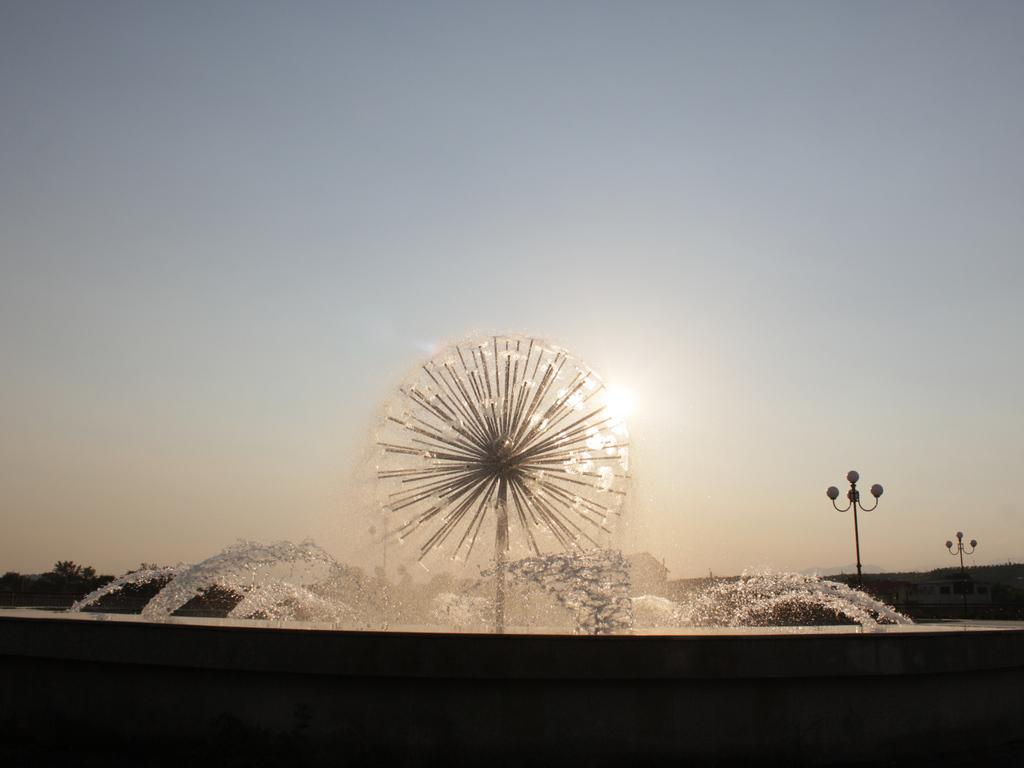What type of lighting can be seen in the image? There are street lights in the image. What natural element is visible in the image? There is water visible in the image. What can be seen in the background of the image? There are trees and the sky visible in the background of the image. Can the sun be seen in the image? Yes, the sun is observable in the sky. What type of fuel is being used by the trees in the image? There is no indication in the image that the trees are using any type of fuel. How does the room in the image appear? There is no room present in the image; it features an outdoor scene with street lights, water, trees, and the sky. 